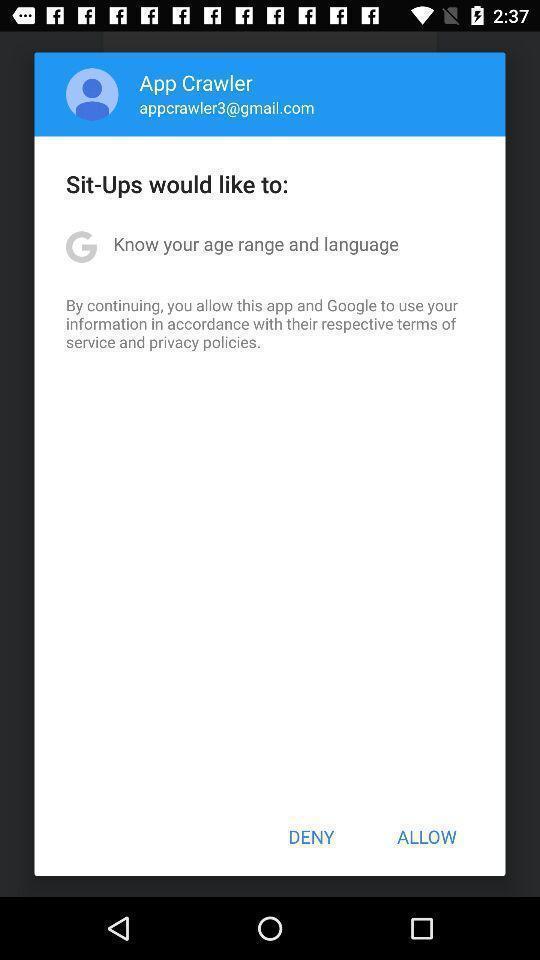Describe the key features of this screenshot. Pop-up shows to continue with an application. 